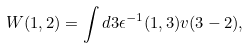<formula> <loc_0><loc_0><loc_500><loc_500>W ( 1 , 2 ) = \int d 3 \epsilon ^ { - 1 } ( 1 , 3 ) v ( 3 - 2 ) ,</formula> 